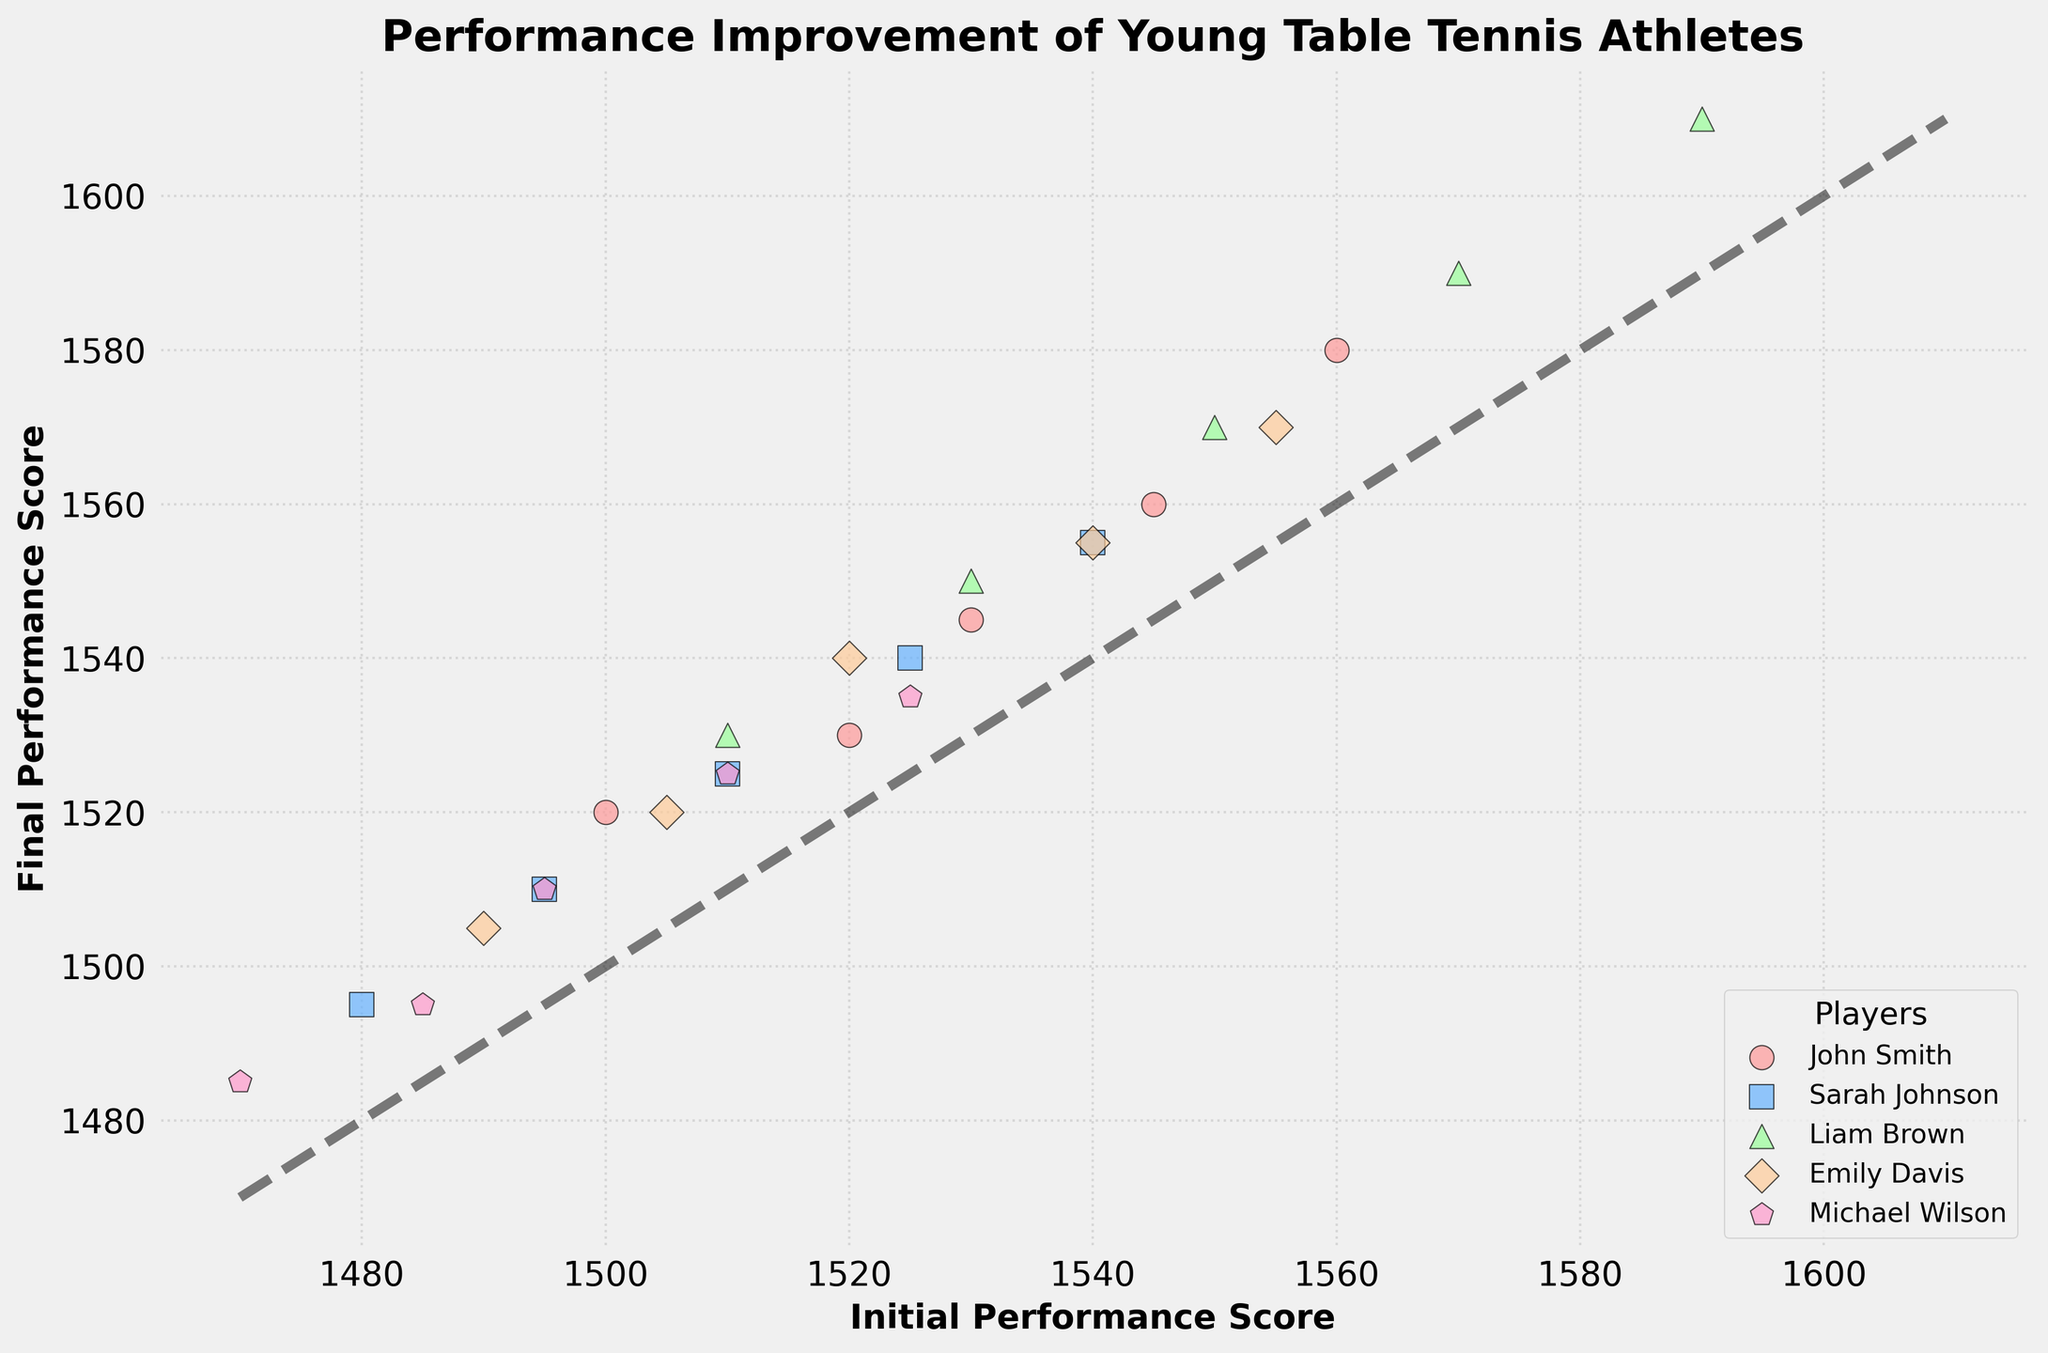What is the title of the plot? The title can be found at the top of the plot and indicates the main topic of the figure.
Answer: Performance Improvement of Young Table Tennis Athletes Which player has the highest initial performance score in the first session? Locate the data points representing each player's performance scores in the first session. Compare the initial scores to find the highest one.
Answer: Liam Brown Are there any players who showed consistent performance improvement across all sessions? Check the scatter plot for a pattern where the final performance score increases with each session for individual players.
Answer: Yes, all players show consistent improvement Which player has the smallest improvement in the final session? Compare the differences between initial and final performance scores for each player in the final session to find the smallest improvement.
Answer: Michael Wilson How many players are represented in the scatter plot? The number of distinct players can be identified by the unique colors and markers used in the scatter plot legend. There are a total of 5 different colors and markers.
Answer: Five What's the difference in final performance scores between John Smith and Liam Brown in the last session? Look at the final performance scores of both players in the last session. Subtract John Smith's score from Liam Brown's score.
Answer: 30 Across all sessions, which player has the steepest improvement trend? Analyze the trajectory of each player's performance data points. Steepest trends can be observed through the slope formed by the points' positions.
Answer: Liam Brown Which player showed the least improvement in their performance score from session 1 to session 5? Calculate the total improvement for each player by subtracting their initial score in session 1 from their final score in session 5. Compare the results to find the smallest improvement.
Answer: Michael Wilson Which data point on the plot is the farthest from the diagonal line? Identify the data point with the largest vertical distance from the diagonal line, which represents equal initial and final scores.
Answer: Liam Brown in session 5 Do any players have final performance scores that are lower than their initial performance scores in any session? Examine the scatter plot for any data points that lie below the diagonal line. If any data points are below this line, it indicates the final score is lower than the initial score.
Answer: No 